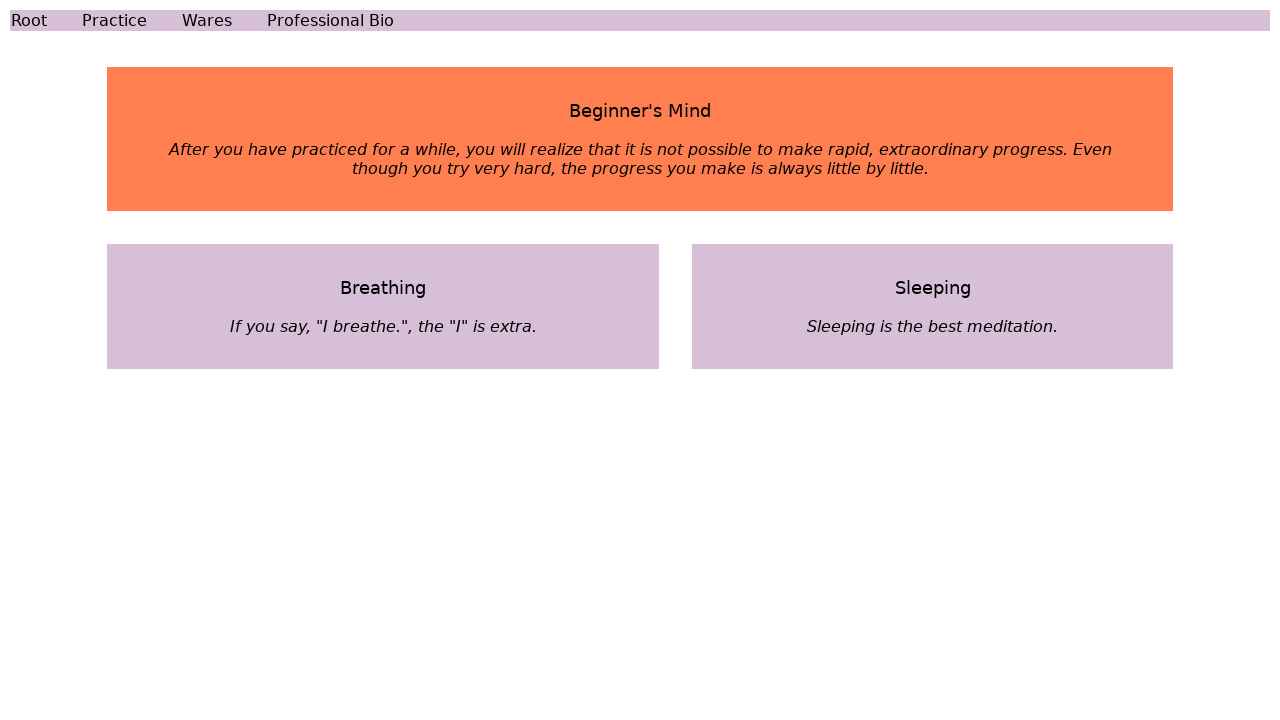How can the layout of this webpage be improved for better user experience? Improving the layout could involve simplifying the navigation links by integrating them into a more structured menu, possibly a horizontal top navigation bar to provide clear access. Additionally, ensuring that the text is legible on all background colors and adding more contrast between the text and background colors could enhance readability and overall user experience. 